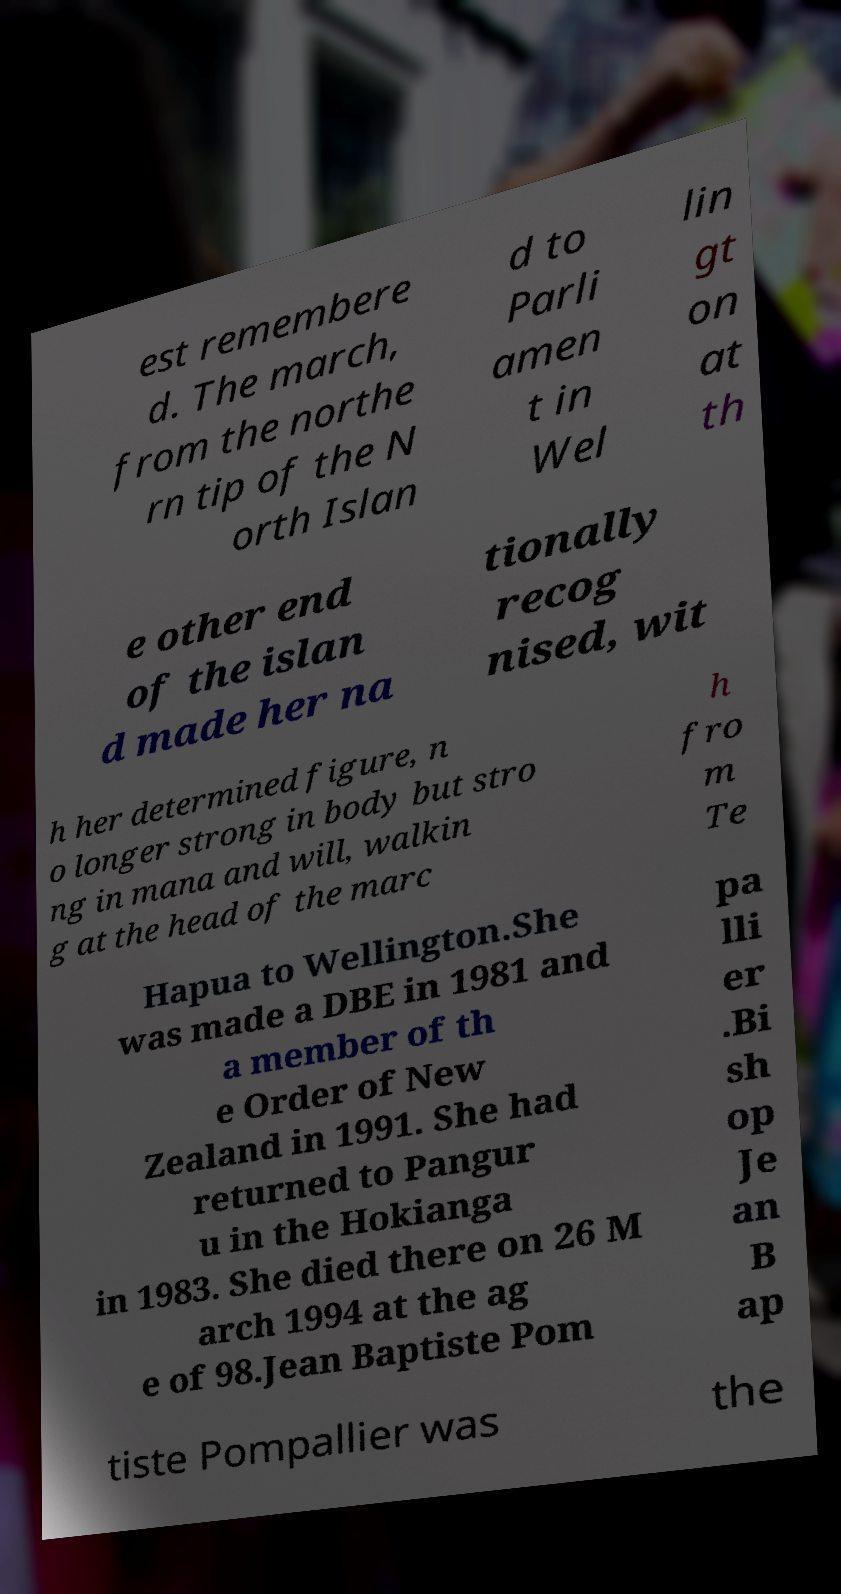Could you assist in decoding the text presented in this image and type it out clearly? est remembere d. The march, from the northe rn tip of the N orth Islan d to Parli amen t in Wel lin gt on at th e other end of the islan d made her na tionally recog nised, wit h her determined figure, n o longer strong in body but stro ng in mana and will, walkin g at the head of the marc h fro m Te Hapua to Wellington.She was made a DBE in 1981 and a member of th e Order of New Zealand in 1991. She had returned to Pangur u in the Hokianga in 1983. She died there on 26 M arch 1994 at the ag e of 98.Jean Baptiste Pom pa lli er .Bi sh op Je an B ap tiste Pompallier was the 